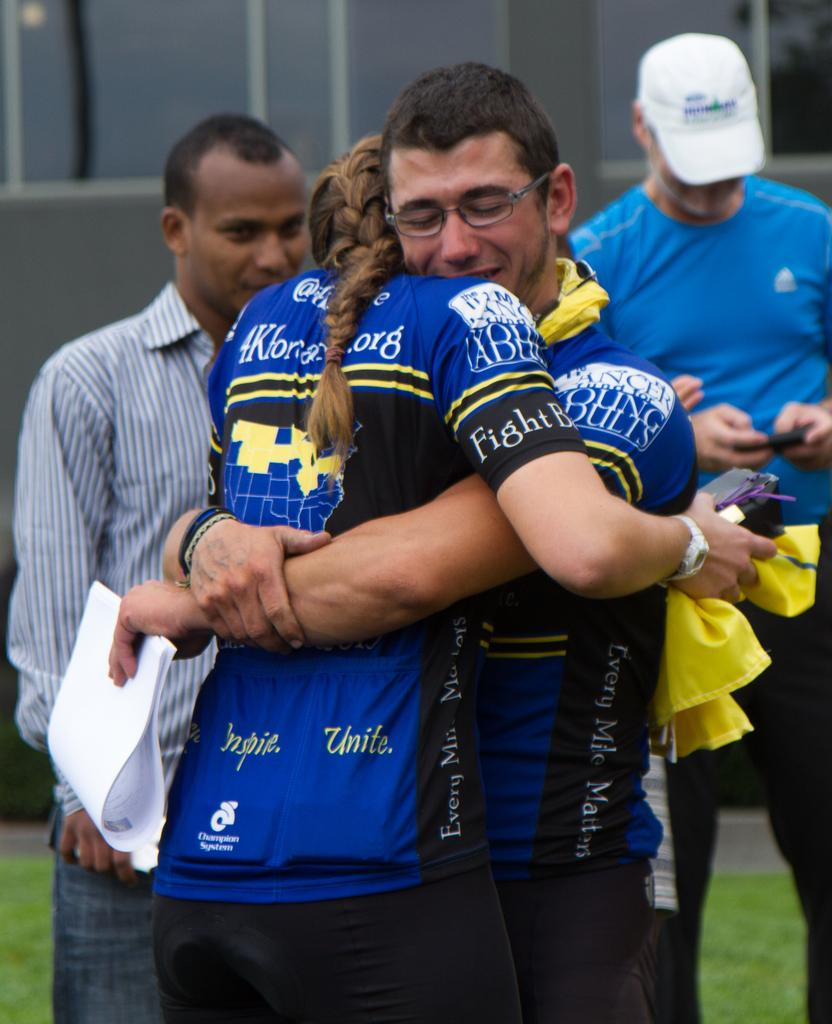<image>
Write a terse but informative summary of the picture. A man and woman in matching shirts that includes the words every mile matters hug. 